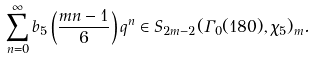Convert formula to latex. <formula><loc_0><loc_0><loc_500><loc_500>\sum _ { n = 0 } ^ { \infty } b _ { 5 } \left ( \frac { m n - 1 } { 6 } \right ) q ^ { n } \in S _ { 2 m - 2 } ( \Gamma _ { 0 } ( 1 8 0 ) , \chi _ { 5 } ) _ { m } .</formula> 